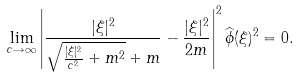Convert formula to latex. <formula><loc_0><loc_0><loc_500><loc_500>\lim _ { c \rightarrow \infty } \left | \frac { | \xi | ^ { 2 } } { \sqrt { \frac { | \xi | ^ { 2 } } { c ^ { 2 } } + m ^ { 2 } } + m } - \frac { | \xi | ^ { 2 } } { 2 m } \right | ^ { 2 } \widehat { \phi } ( \xi ) ^ { 2 } = 0 .</formula> 